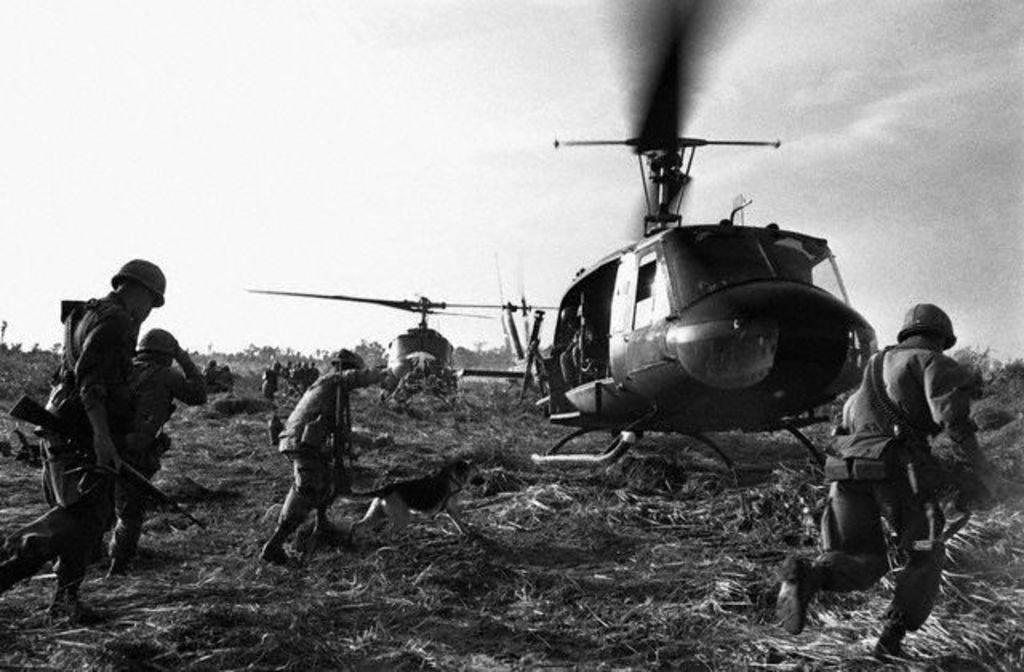How would you summarize this image in a sentence or two? In this image on the right side there is a helicopter, and in the background there is another helicopter and there are a group of people who are holding guns and wearing helmets. At the bottom there is grass, and in the background there are trees, at the top there is sky. 